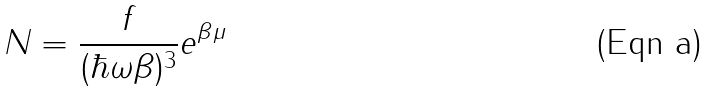<formula> <loc_0><loc_0><loc_500><loc_500>N = \frac { f } { ( \hbar { \omega } \beta ) ^ { 3 } } e ^ { \beta \mu }</formula> 